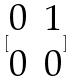Convert formula to latex. <formula><loc_0><loc_0><loc_500><loc_500>[ \begin{matrix} 0 & 1 \\ 0 & 0 \end{matrix} ]</formula> 